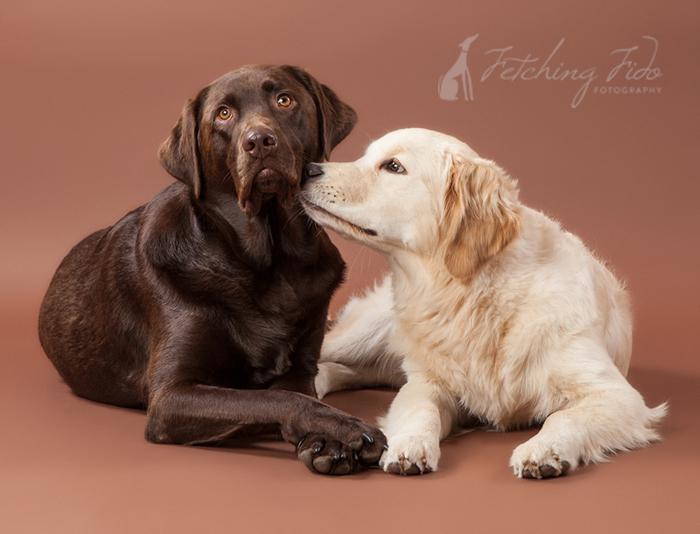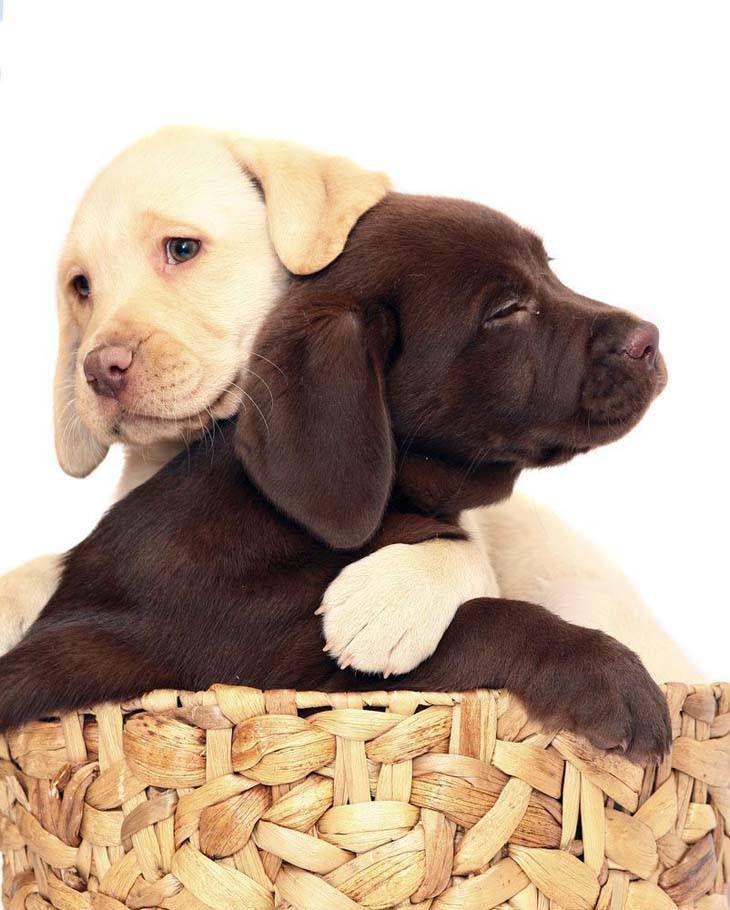The first image is the image on the left, the second image is the image on the right. Evaluate the accuracy of this statement regarding the images: "There are three dogs in one picture and two in the other picture.". Is it true? Answer yes or no. No. The first image is the image on the left, the second image is the image on the right. Given the left and right images, does the statement "There are a total of 2 adult Labradors interacting with each other." hold true? Answer yes or no. Yes. 